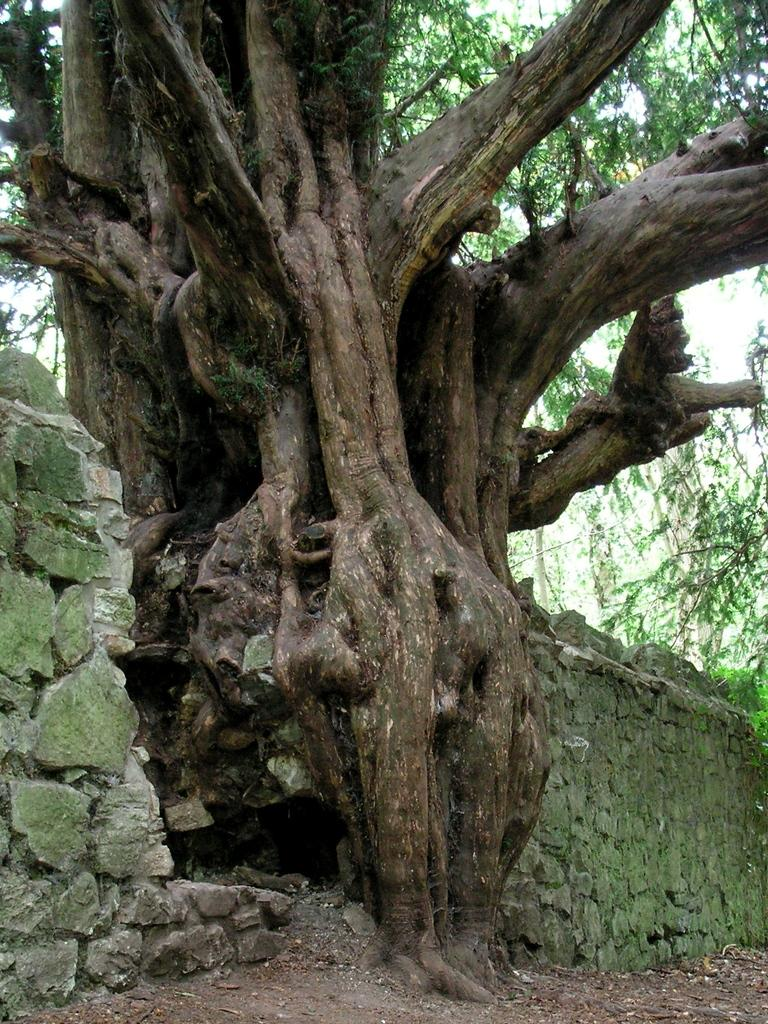What is the main subject in the middle of the image? There is a big tree in the middle of the image. Where is the tree located? The tree is on the ground. What surrounds the tree on both sides? There is a stone wall on both sides of the tree. What can be seen in the background of the image? There are trees visible in the background of the image. What time of day is the father shown sleeping in the image? There is no father or sleeping person present in the image; it features a big tree with stone walls on both sides and trees in the background. 